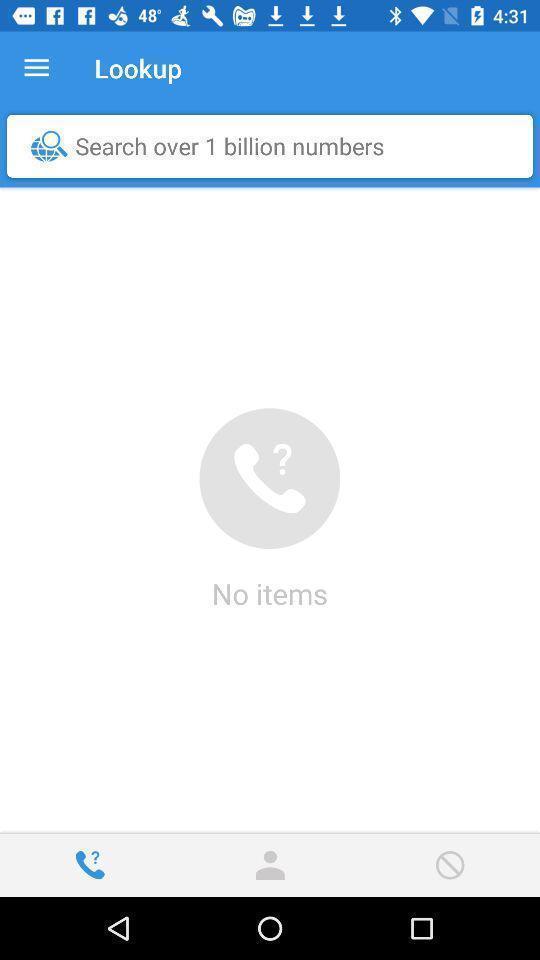Give me a narrative description of this picture. Screen displaying a search bar in contacts page. 